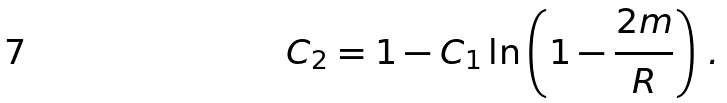<formula> <loc_0><loc_0><loc_500><loc_500>C _ { 2 } = 1 - C _ { 1 } \ln \left ( 1 - \frac { 2 m } { R } \right ) \, .</formula> 